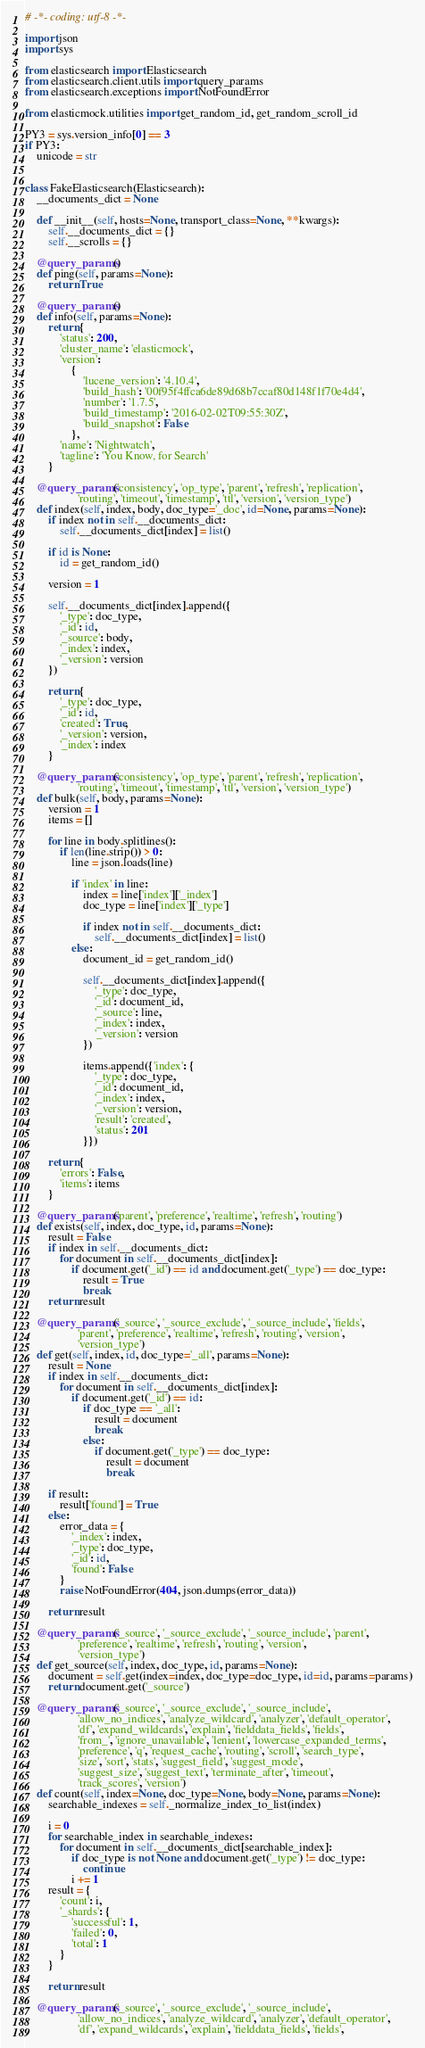Convert code to text. <code><loc_0><loc_0><loc_500><loc_500><_Python_># -*- coding: utf-8 -*-

import json
import sys

from elasticsearch import Elasticsearch
from elasticsearch.client.utils import query_params
from elasticsearch.exceptions import NotFoundError

from elasticmock.utilities import get_random_id, get_random_scroll_id

PY3 = sys.version_info[0] == 3
if PY3:
    unicode = str


class FakeElasticsearch(Elasticsearch):
    __documents_dict = None

    def __init__(self, hosts=None, transport_class=None, **kwargs):
        self.__documents_dict = {}
        self.__scrolls = {}

    @query_params()
    def ping(self, params=None):
        return True

    @query_params()
    def info(self, params=None):
        return {
            'status': 200,
            'cluster_name': 'elasticmock',
            'version':
                {
                    'lucene_version': '4.10.4',
                    'build_hash': '00f95f4ffca6de89d68b7ccaf80d148f1f70e4d4',
                    'number': '1.7.5',
                    'build_timestamp': '2016-02-02T09:55:30Z',
                    'build_snapshot': False
                },
            'name': 'Nightwatch',
            'tagline': 'You Know, for Search'
        }

    @query_params('consistency', 'op_type', 'parent', 'refresh', 'replication',
                  'routing', 'timeout', 'timestamp', 'ttl', 'version', 'version_type')
    def index(self, index, body, doc_type='_doc', id=None, params=None):
        if index not in self.__documents_dict:
            self.__documents_dict[index] = list()

        if id is None:
            id = get_random_id()

        version = 1

        self.__documents_dict[index].append({
            '_type': doc_type,
            '_id': id,
            '_source': body,
            '_index': index,
            '_version': version
        })

        return {
            '_type': doc_type,
            '_id': id,
            'created': True,
            '_version': version,
            '_index': index
        }

    @query_params('consistency', 'op_type', 'parent', 'refresh', 'replication',
                  'routing', 'timeout', 'timestamp', 'ttl', 'version', 'version_type')
    def bulk(self, body, params=None):
        version = 1
        items = []

        for line in body.splitlines():
            if len(line.strip()) > 0:
                line = json.loads(line)

                if 'index' in line:
                    index = line['index']['_index']
                    doc_type = line['index']['_type']

                    if index not in self.__documents_dict:
                        self.__documents_dict[index] = list()
                else:
                    document_id = get_random_id()

                    self.__documents_dict[index].append({
                        '_type': doc_type,
                        '_id': document_id,
                        '_source': line,
                        '_index': index,
                        '_version': version
                    })

                    items.append({'index': {
                        '_type': doc_type,
                        '_id': document_id,
                        '_index': index,
                        '_version': version,
                        'result': 'created',
                        'status': 201
                    }})

        return {
            'errors': False,
            'items': items
        }

    @query_params('parent', 'preference', 'realtime', 'refresh', 'routing')
    def exists(self, index, doc_type, id, params=None):
        result = False
        if index in self.__documents_dict:
            for document in self.__documents_dict[index]:
                if document.get('_id') == id and document.get('_type') == doc_type:
                    result = True
                    break
        return result

    @query_params('_source', '_source_exclude', '_source_include', 'fields',
                  'parent', 'preference', 'realtime', 'refresh', 'routing', 'version',
                  'version_type')
    def get(self, index, id, doc_type='_all', params=None):
        result = None
        if index in self.__documents_dict:
            for document in self.__documents_dict[index]:
                if document.get('_id') == id:
                    if doc_type == '_all':
                        result = document
                        break
                    else:
                        if document.get('_type') == doc_type:
                            result = document
                            break

        if result:
            result['found'] = True
        else:
            error_data = {
                '_index': index,
                '_type': doc_type,
                '_id': id,
                'found': False
            }
            raise NotFoundError(404, json.dumps(error_data))

        return result

    @query_params('_source', '_source_exclude', '_source_include', 'parent',
                  'preference', 'realtime', 'refresh', 'routing', 'version',
                  'version_type')
    def get_source(self, index, doc_type, id, params=None):
        document = self.get(index=index, doc_type=doc_type, id=id, params=params)
        return document.get('_source')

    @query_params('_source', '_source_exclude', '_source_include',
                  'allow_no_indices', 'analyze_wildcard', 'analyzer', 'default_operator',
                  'df', 'expand_wildcards', 'explain', 'fielddata_fields', 'fields',
                  'from_', 'ignore_unavailable', 'lenient', 'lowercase_expanded_terms',
                  'preference', 'q', 'request_cache', 'routing', 'scroll', 'search_type',
                  'size', 'sort', 'stats', 'suggest_field', 'suggest_mode',
                  'suggest_size', 'suggest_text', 'terminate_after', 'timeout',
                  'track_scores', 'version')
    def count(self, index=None, doc_type=None, body=None, params=None):
        searchable_indexes = self._normalize_index_to_list(index)

        i = 0
        for searchable_index in searchable_indexes:
            for document in self.__documents_dict[searchable_index]:
                if doc_type is not None and document.get('_type') != doc_type:
                    continue
                i += 1
        result = {
            'count': i,
            '_shards': {
                'successful': 1,
                'failed': 0,
                'total': 1
            }
        }

        return result

    @query_params('_source', '_source_exclude', '_source_include',
                  'allow_no_indices', 'analyze_wildcard', 'analyzer', 'default_operator',
                  'df', 'expand_wildcards', 'explain', 'fielddata_fields', 'fields',</code> 